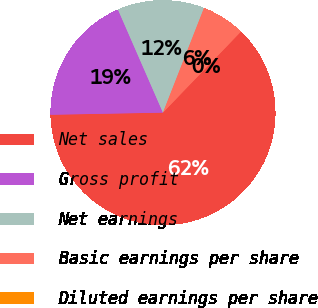Convert chart. <chart><loc_0><loc_0><loc_500><loc_500><pie_chart><fcel>Net sales<fcel>Gross profit<fcel>Net earnings<fcel>Basic earnings per share<fcel>Diluted earnings per share<nl><fcel>62.5%<fcel>18.75%<fcel>12.5%<fcel>6.25%<fcel>0.0%<nl></chart> 